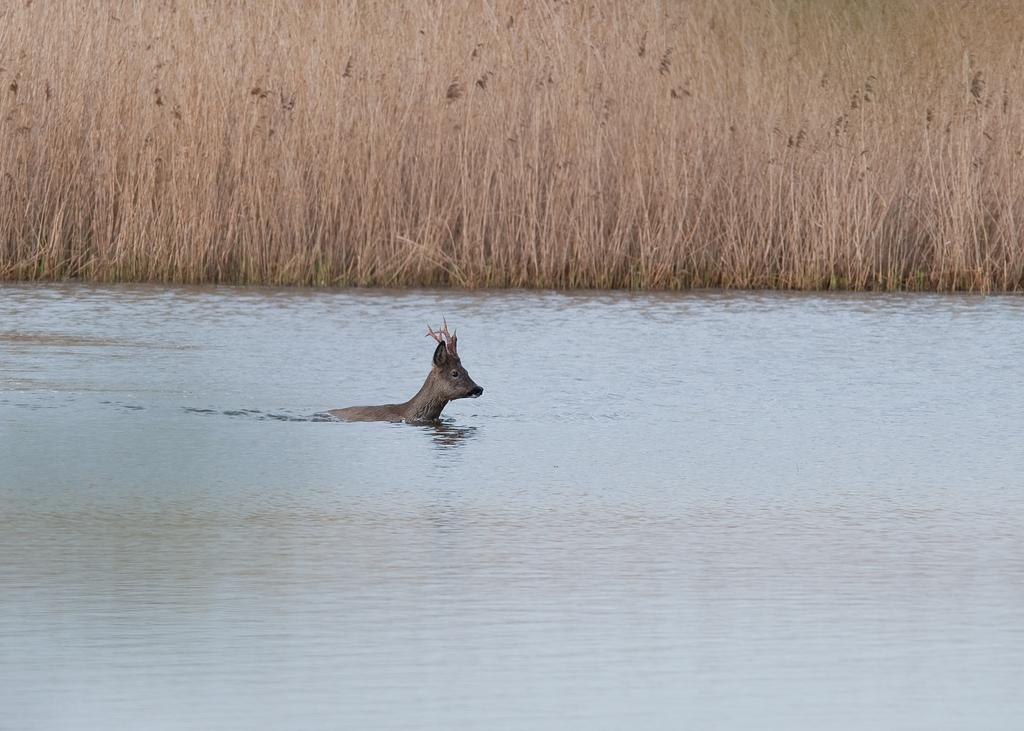What is the animal doing in the water? The fact provided does not specify what the animal is doing in the water. Can you describe the dried plants on the land? The dried plants are located at the top of the image. How many sheets of paper are floating in the water with the animal? There is no mention of paper in the image, so we cannot determine the number of sheets floating in the water. 